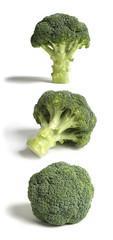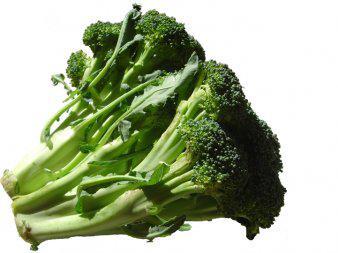The first image is the image on the left, the second image is the image on the right. For the images displayed, is the sentence "A total of five cut broccoli florets are shown." factually correct? Answer yes or no. No. 